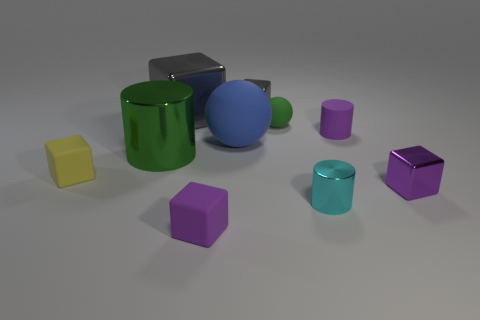Subtract all metallic cylinders. How many cylinders are left? 1 Subtract 1 cylinders. How many cylinders are left? 2 Subtract all green cylinders. How many cylinders are left? 2 Subtract all cylinders. How many objects are left? 7 Subtract all cyan cylinders. How many blue spheres are left? 1 Subtract 0 cyan spheres. How many objects are left? 10 Subtract all green blocks. Subtract all red cylinders. How many blocks are left? 5 Subtract all yellow blocks. Subtract all purple objects. How many objects are left? 6 Add 4 tiny green objects. How many tiny green objects are left? 5 Add 4 large gray shiny things. How many large gray shiny things exist? 5 